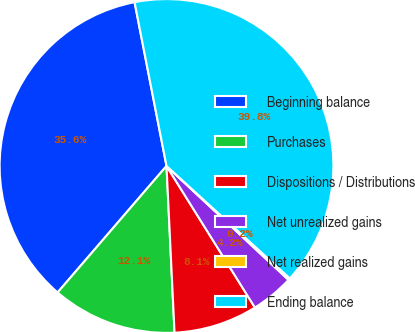<chart> <loc_0><loc_0><loc_500><loc_500><pie_chart><fcel>Beginning balance<fcel>Purchases<fcel>Dispositions / Distributions<fcel>Net unrealized gains<fcel>Net realized gains<fcel>Ending balance<nl><fcel>35.62%<fcel>12.08%<fcel>8.12%<fcel>4.16%<fcel>0.19%<fcel>39.83%<nl></chart> 